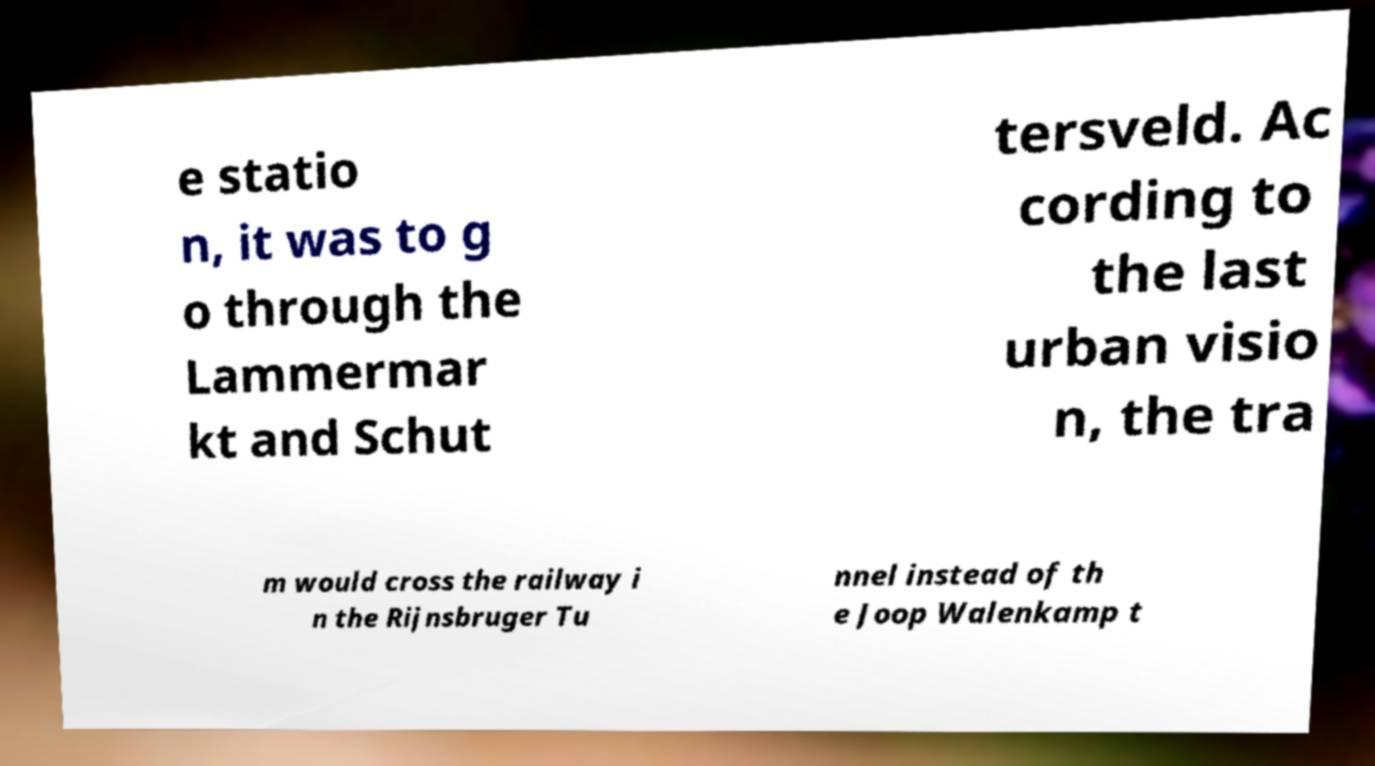Could you extract and type out the text from this image? e statio n, it was to g o through the Lammermar kt and Schut tersveld. Ac cording to the last urban visio n, the tra m would cross the railway i n the Rijnsbruger Tu nnel instead of th e Joop Walenkamp t 